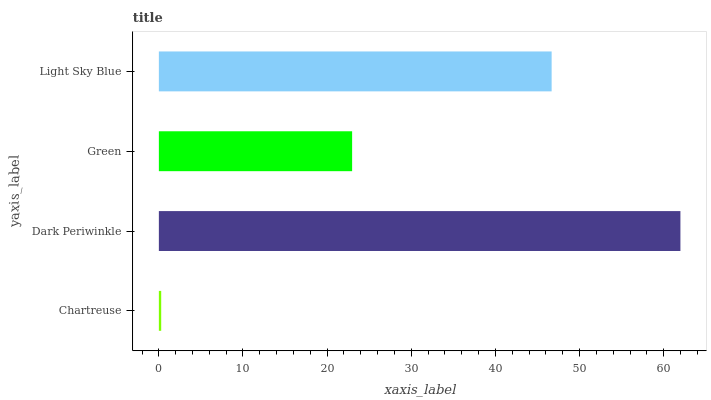Is Chartreuse the minimum?
Answer yes or no. Yes. Is Dark Periwinkle the maximum?
Answer yes or no. Yes. Is Green the minimum?
Answer yes or no. No. Is Green the maximum?
Answer yes or no. No. Is Dark Periwinkle greater than Green?
Answer yes or no. Yes. Is Green less than Dark Periwinkle?
Answer yes or no. Yes. Is Green greater than Dark Periwinkle?
Answer yes or no. No. Is Dark Periwinkle less than Green?
Answer yes or no. No. Is Light Sky Blue the high median?
Answer yes or no. Yes. Is Green the low median?
Answer yes or no. Yes. Is Dark Periwinkle the high median?
Answer yes or no. No. Is Chartreuse the low median?
Answer yes or no. No. 